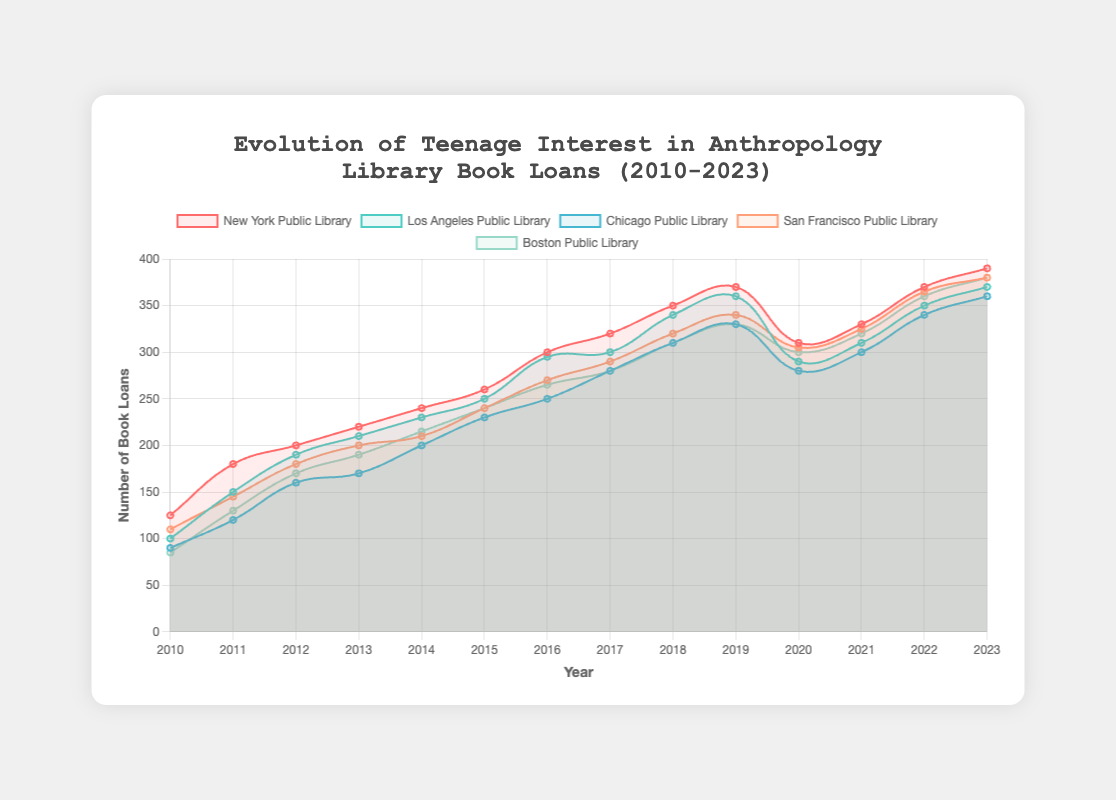Which library had the highest number of book loans in 2023? Look for the 2023 data point for each library on the graph and find the one with the highest value.
Answer: New York Public Library What is the overall trend for the Chicago Public Library from 2010 to 2023? Observe the data points for Chicago Public Library from 2010 to 2023. Notice if the values generally increase, decrease, or remain stable over time.
Answer: Increasing In which year did the New York Public Library and the Los Angeles Public Library have the same number of book loans? Identify the points where the lines for New York Public Library and Los Angeles Public Library intersect on the graph.
Answer: 2018 Which year had the lowest number of book loans for San Francisco Public Library? Find the lowest data point on the graph line representing San Francisco Public Library.
Answer: 2010 By how much did the Boston Public Library's book loans increase from 2015 to 2023? Calculate the difference between the values for Boston Public Library in 2023 and 2015.
Answer: 140 Which library saw the largest increase in book loans between 2020 and 2021? Calculate the difference in loans between 2020 and 2021 for each library, and determine which library had the highest increase.
Answer: San Francisco Public Library What is the average number of book loans for the New York Public Library over the entire period? Sum the loan data for New York Public Library from all years and divide by the number of years (14).
Answer: Approximately 282.14 Compare the trend lines for Los Angeles Public Library and Chicago Public Library from 2016 to 2020. What do you observe? Analyze the data points for both libraries between 2016 and 2020, noting any major patterns or differences in their trends.
Answer: Both libraries show an initial increase, then a slight decline Which library had the most consistent growth in book loans from 2010 to 2023? Look for the library with the most steadily increasing line on the graph, without major fluctuations.
Answer: New York Public Library Based on the colors of the lines, identify which color represents the Boston Public Library. Observe the legend on the chart to match Boston Public Library with its corresponding line color.
Answer: Green 